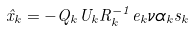<formula> <loc_0><loc_0><loc_500><loc_500>\hat { x } _ { k } = - Q _ { k } U _ { k } R _ { k } ^ { - 1 } e _ { k } \nu \alpha _ { k } s _ { k }</formula> 